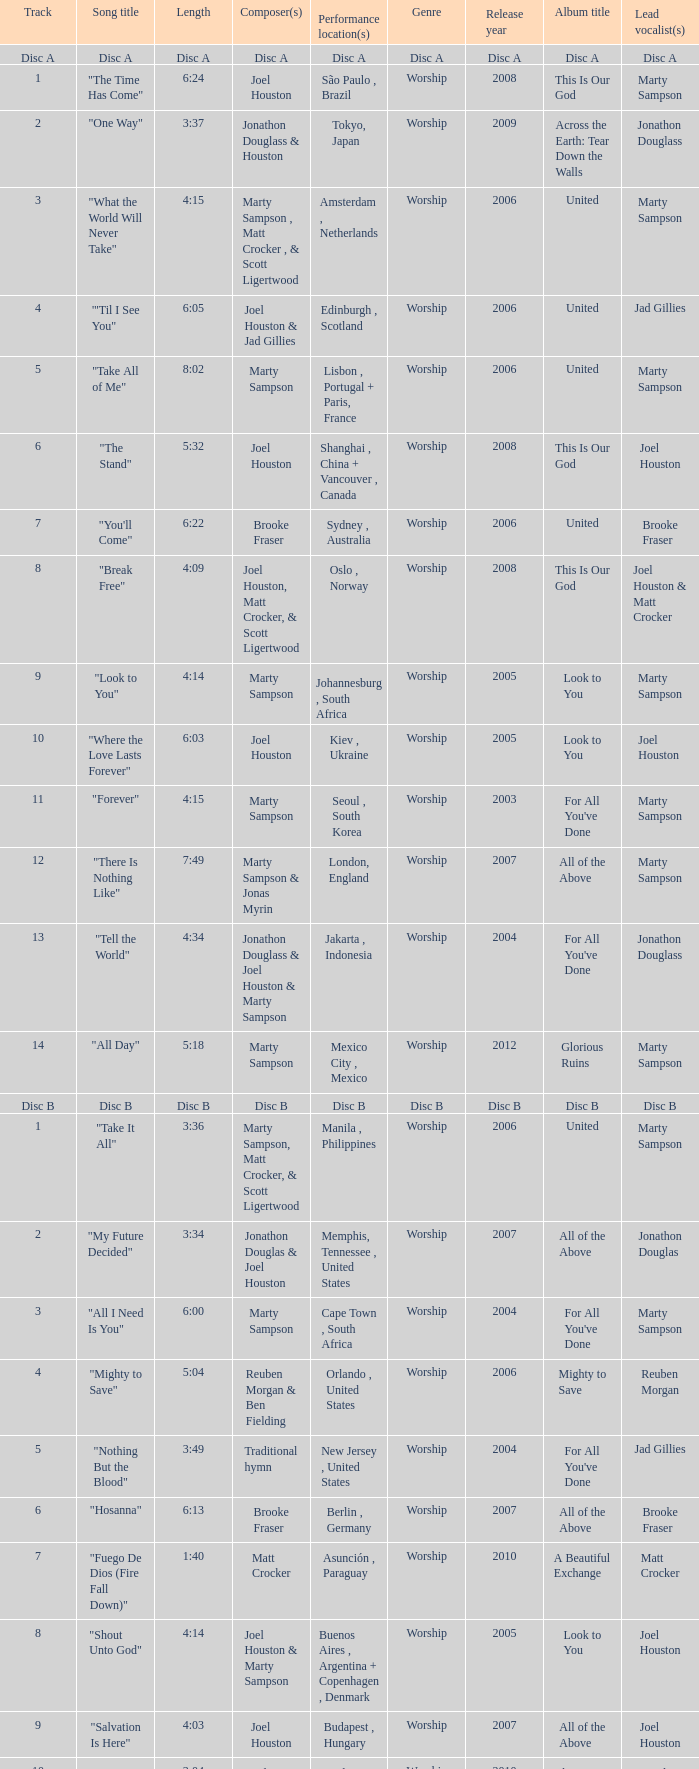Who is the composer of the song with a length of 6:24? Joel Houston. Could you help me parse every detail presented in this table? {'header': ['Track', 'Song title', 'Length', 'Composer(s)', 'Performance location(s)', 'Genre', 'Release year', 'Album title', 'Lead vocalist(s)'], 'rows': [['Disc A', 'Disc A', 'Disc A', 'Disc A', 'Disc A', 'Disc A', 'Disc A', 'Disc A', 'Disc A'], ['1', '"The Time Has Come"', '6:24', 'Joel Houston', 'São Paulo , Brazil', 'Worship', '2008', 'This Is Our God', 'Marty Sampson'], ['2', '"One Way"', '3:37', 'Jonathon Douglass & Houston', 'Tokyo, Japan', 'Worship', '2009', 'Across the Earth: Tear Down the Walls', 'Jonathon Douglass'], ['3', '"What the World Will Never Take"', '4:15', 'Marty Sampson , Matt Crocker , & Scott Ligertwood', 'Amsterdam , Netherlands', 'Worship', '2006', 'United', 'Marty Sampson'], ['4', '"\'Til I See You"', '6:05', 'Joel Houston & Jad Gillies', 'Edinburgh , Scotland', 'Worship', '2006', 'United', 'Jad Gillies'], ['5', '"Take All of Me"', '8:02', 'Marty Sampson', 'Lisbon , Portugal + Paris, France', 'Worship', '2006', 'United', 'Marty Sampson'], ['6', '"The Stand"', '5:32', 'Joel Houston', 'Shanghai , China + Vancouver , Canada', 'Worship', '2008', 'This Is Our God', 'Joel Houston'], ['7', '"You\'ll Come"', '6:22', 'Brooke Fraser', 'Sydney , Australia', 'Worship', '2006', 'United', 'Brooke Fraser'], ['8', '"Break Free"', '4:09', 'Joel Houston, Matt Crocker, & Scott Ligertwood', 'Oslo , Norway', 'Worship', '2008', 'This Is Our God', 'Joel Houston & Matt Crocker'], ['9', '"Look to You"', '4:14', 'Marty Sampson', 'Johannesburg , South Africa', 'Worship', '2005', 'Look to You', 'Marty Sampson'], ['10', '"Where the Love Lasts Forever"', '6:03', 'Joel Houston', 'Kiev , Ukraine', 'Worship', '2005', 'Look to You', 'Joel Houston '], ['11', '"Forever"', '4:15', 'Marty Sampson', 'Seoul , South Korea', 'Worship', '2003', "For All You've Done", 'Marty Sampson'], ['12', '"There Is Nothing Like"', '7:49', 'Marty Sampson & Jonas Myrin', 'London, England', 'Worship', '2007', 'All of the Above', 'Marty Sampson'], ['13', '"Tell the World"', '4:34', 'Jonathon Douglass & Joel Houston & Marty Sampson', 'Jakarta , Indonesia', 'Worship', '2004', "For All You've Done", 'Jonathon Douglass'], ['14', '"All Day"', '5:18', 'Marty Sampson', 'Mexico City , Mexico', 'Worship', '2012', 'Glorious Ruins', 'Marty Sampson'], ['Disc B', 'Disc B', 'Disc B', 'Disc B', 'Disc B', 'Disc B', 'Disc B', 'Disc B', 'Disc B'], ['1', '"Take It All"', '3:36', 'Marty Sampson, Matt Crocker, & Scott Ligertwood', 'Manila , Philippines', 'Worship', '2006', 'United', 'Marty Sampson'], ['2', '"My Future Decided"', '3:34', 'Jonathon Douglas & Joel Houston', 'Memphis, Tennessee , United States', 'Worship', '2007', 'All of the Above', 'Jonathon Douglas'], ['3', '"All I Need Is You"', '6:00', 'Marty Sampson', 'Cape Town , South Africa', 'Worship', '2004', "For All You've Done", 'Marty Sampson'], ['4', '"Mighty to Save"', '5:04', 'Reuben Morgan & Ben Fielding', 'Orlando , United States', 'Worship', '2006', 'Mighty to Save', 'Reuben Morgan'], ['5', '"Nothing But the Blood"', '3:49', 'Traditional hymn', 'New Jersey , United States', 'Worship', '2004', "For All You've Done", 'Jad Gillies'], ['6', '"Hosanna"', '6:13', 'Brooke Fraser', 'Berlin , Germany', 'Worship', '2007', 'All of the Above', 'Brooke Fraser'], ['7', '"Fuego De Dios (Fire Fall Down)"', '1:40', 'Matt Crocker', 'Asunción , Paraguay', 'Worship', '2010', 'A Beautiful Exchange', 'Matt Crocker'], ['8', '"Shout Unto God"', '4:14', 'Joel Houston & Marty Sampson', 'Buenos Aires , Argentina + Copenhagen , Denmark', 'Worship', '2005', 'Look to You', 'Joel Houston'], ['9', '"Salvation Is Here"', '4:03', 'Joel Houston', 'Budapest , Hungary', 'Worship', '2007', 'All of the Above', 'Joel Houston'], ['10', '"Love Enough"', '3:04', 'Braden Lang & Scott Ligertwood', 'Sydney, Australia', 'Worship', '2010', 'This Is Our God', 'Braden Lang'], ['11', '"More Than Life"', '6:29', 'Morgan', 'Orlando, United States', 'Worship', '2003', "For All You've Done", 'Jad Gillies & Joel Houston'], ['12', '"None But Jesus"', '7:58', 'Brooke Fraser', 'Toronto , Canada + Buenos Aires, Argentina', 'Worship', '2006', 'United', 'Brooke Fraser'], ['13', '"From the Inside Out"', '5:59', 'Joel Houston', 'Rio de Janeiro , Brazil', 'Worship', '2006', 'United', 'Joel Houston'], ['14', '"Came to My Rescue"', '3:43', 'Marty Sampson, Dylan Thomas, & Joel Davies', 'Kuala Lumpur , Malaysia', 'Worship', '2005', 'Look to You', 'Marty Sampson '], ['15', '"Saviour King"', '7:03', 'Marty Sampson & Mia Fieldes', 'Västerås , Sweden', 'Worship', '2007', 'All of the Above', 'Marty Sampson'], ['16', '"Solution"', '5:55', 'Joel Houston & Matt Crocker', 'Los Angeles , United States', 'Worship', '2011', 'Aftermath', 'Joel Houston & Matt Crocker']]} 